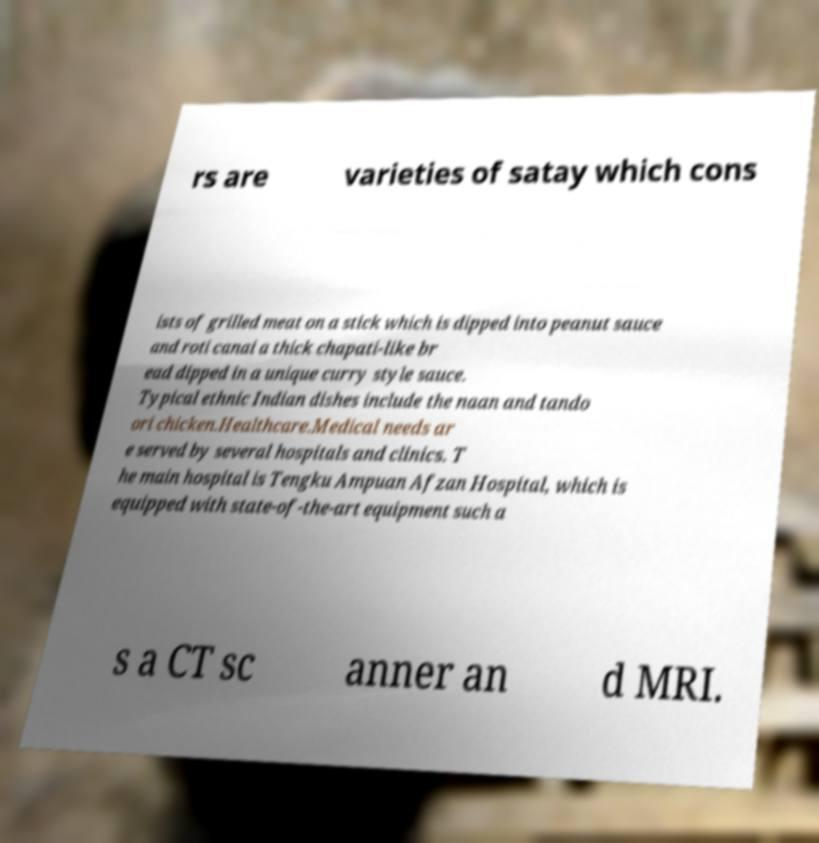I need the written content from this picture converted into text. Can you do that? rs are varieties of satay which cons ists of grilled meat on a stick which is dipped into peanut sauce and roti canai a thick chapati-like br ead dipped in a unique curry style sauce. Typical ethnic Indian dishes include the naan and tando ori chicken.Healthcare.Medical needs ar e served by several hospitals and clinics. T he main hospital is Tengku Ampuan Afzan Hospital, which is equipped with state-of-the-art equipment such a s a CT sc anner an d MRI. 